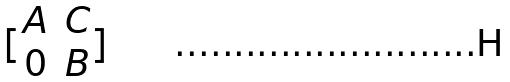Convert formula to latex. <formula><loc_0><loc_0><loc_500><loc_500>[ \begin{matrix} A & C \\ 0 & B \end{matrix} ]</formula> 